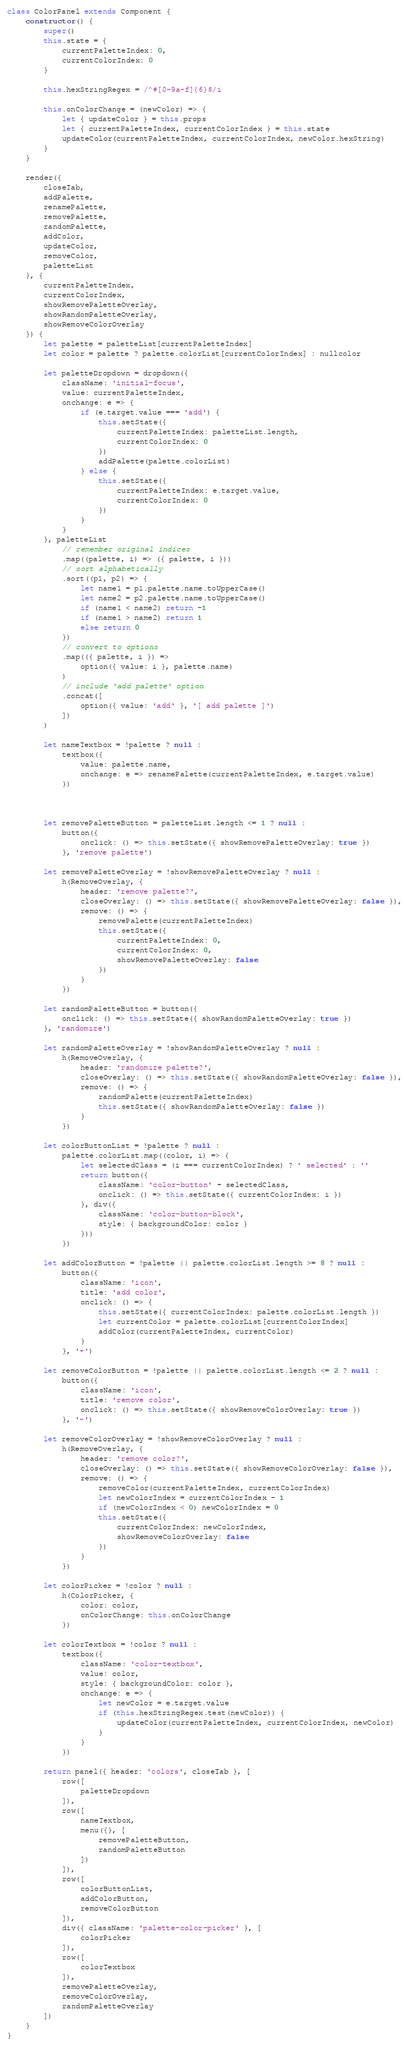<code> <loc_0><loc_0><loc_500><loc_500><_JavaScript_>class ColorPanel extends Component {
    constructor() {
        super()
        this.state = {
            currentPaletteIndex: 0,
            currentColorIndex: 0
        }

        this.hexStringRegex = /^#[0-9a-f]{6}$/i

        this.onColorChange = (newColor) => {
            let { updateColor } = this.props
            let { currentPaletteIndex, currentColorIndex } = this.state
            updateColor(currentPaletteIndex, currentColorIndex, newColor.hexString)
        }
    }

    render({
        closeTab,
        addPalette,
        renamePalette,
        removePalette,
        randomPalette,
        addColor,
        updateColor,
        removeColor,
        paletteList
    }, {
        currentPaletteIndex,
        currentColorIndex,
        showRemovePaletteOverlay,
        showRandomPaletteOverlay,
        showRemoveColorOverlay
    }) {
        let palette = paletteList[currentPaletteIndex]
        let color = palette ? palette.colorList[currentColorIndex] : nullcolor

        let paletteDropdown = dropdown({
            className: 'initial-focus',
            value: currentPaletteIndex,
            onchange: e => {
                if (e.target.value === 'add') {
                    this.setState({
                        currentPaletteIndex: paletteList.length,
                        currentColorIndex: 0
                    })
                    addPalette(palette.colorList)
                } else {
                    this.setState({ 
                        currentPaletteIndex: e.target.value,
                        currentColorIndex: 0
                    })
                }
            }
        }, paletteList
            // remember original indices
            .map((palette, i) => ({ palette, i }))
            // sort alphabetically
            .sort((p1, p2) => {
                let name1 = p1.palette.name.toUpperCase()
                let name2 = p2.palette.name.toUpperCase()
                if (name1 < name2) return -1
                if (name1 > name2) return 1
                else return 0
            })
            // convert to options
            .map(({ palette, i }) =>
                option({ value: i }, palette.name)
            )
            // include 'add palette' option
            .concat([
                option({ value: 'add' }, '[ add palette ]')
            ])
        )
        
        let nameTextbox = !palette ? null :
            textbox({
                value: palette.name,
                onchange: e => renamePalette(currentPaletteIndex, e.target.value)
            })



        let removePaletteButton = paletteList.length <= 1 ? null :
            button({
                onclick: () => this.setState({ showRemovePaletteOverlay: true })
            }, 'remove palette')

        let removePaletteOverlay = !showRemovePaletteOverlay ? null :
            h(RemoveOverlay, {
                header: 'remove palette?',
                closeOverlay: () => this.setState({ showRemovePaletteOverlay: false }),
                remove: () => {
                    removePalette(currentPaletteIndex)
                    this.setState({
                        currentPaletteIndex: 0,
                        currentColorIndex: 0,
                        showRemovePaletteOverlay: false
                    })
                }
            })

        let randomPaletteButton = button({
            onclick: () => this.setState({ showRandomPaletteOverlay: true })
        }, 'randomize')

        let randomPaletteOverlay = !showRandomPaletteOverlay ? null :
            h(RemoveOverlay, {
                header: 'randomize palette?',
                closeOverlay: () => this.setState({ showRandomPaletteOverlay: false }),
                remove: () => {
                    randomPalette(currentPaletteIndex)
                    this.setState({ showRandomPaletteOverlay: false })
                }
            })

        let colorButtonList = !palette ? null :
            palette.colorList.map((color, i) => {
                let selectedClass = (i === currentColorIndex) ? ' selected' : ''
                return button({
                    className: 'color-button' + selectedClass,
                    onclick: () => this.setState({ currentColorIndex: i })
                }, div({
                    className: 'color-button-block',
                    style: { backgroundColor: color }
                }))
            })

        let addColorButton = !palette || palette.colorList.length >= 8 ? null :
            button({
                className: 'icon',
                title: 'add color',
                onclick: () => {
                    this.setState({ currentColorIndex: palette.colorList.length })
                    let currentColor = palette.colorList[currentColorIndex]
                    addColor(currentPaletteIndex, currentColor)
                }
            }, '+')

        let removeColorButton = !palette || palette.colorList.length <= 2 ? null :
            button({
                className: 'icon',
                title: 'remove color',
                onclick: () => this.setState({ showRemoveColorOverlay: true })
            }, '-')

        let removeColorOverlay = !showRemoveColorOverlay ? null :
            h(RemoveOverlay, {
                header: 'remove color?',
                closeOverlay: () => this.setState({ showRemoveColorOverlay: false }),
                remove: () => {
                    removeColor(currentPaletteIndex, currentColorIndex)
                    let newColorIndex = currentColorIndex - 1
                    if (newColorIndex < 0) newColorIndex = 0
                    this.setState({
                        currentColorIndex: newColorIndex,
                        showRemoveColorOverlay: false
                    })
                }
            })

        let colorPicker = !color ? null :
            h(ColorPicker, {
                color: color,
                onColorChange: this.onColorChange
            })
        
        let colorTextbox = !color ? null :
            textbox({
                className: 'color-textbox',
                value: color,
                style: { backgroundColor: color },
                onchange: e => {
                    let newColor = e.target.value
                    if (this.hexStringRegex.test(newColor)) {
                        updateColor(currentPaletteIndex, currentColorIndex, newColor)
                    }
                }
            })

        return panel({ header: 'colors', closeTab }, [
            row([
                paletteDropdown
            ]),
            row([
                nameTextbox,
                menu({}, [
                    removePaletteButton,
                    randomPaletteButton
                ])
            ]),
            row([
                colorButtonList,
                addColorButton,
                removeColorButton
            ]),
            div({ className: 'palette-color-picker' }, [
                colorPicker
            ]),
            row([
                colorTextbox
            ]),
            removePaletteOverlay,
            removeColorOverlay,
            randomPaletteOverlay
        ])
    }
}
</code> 